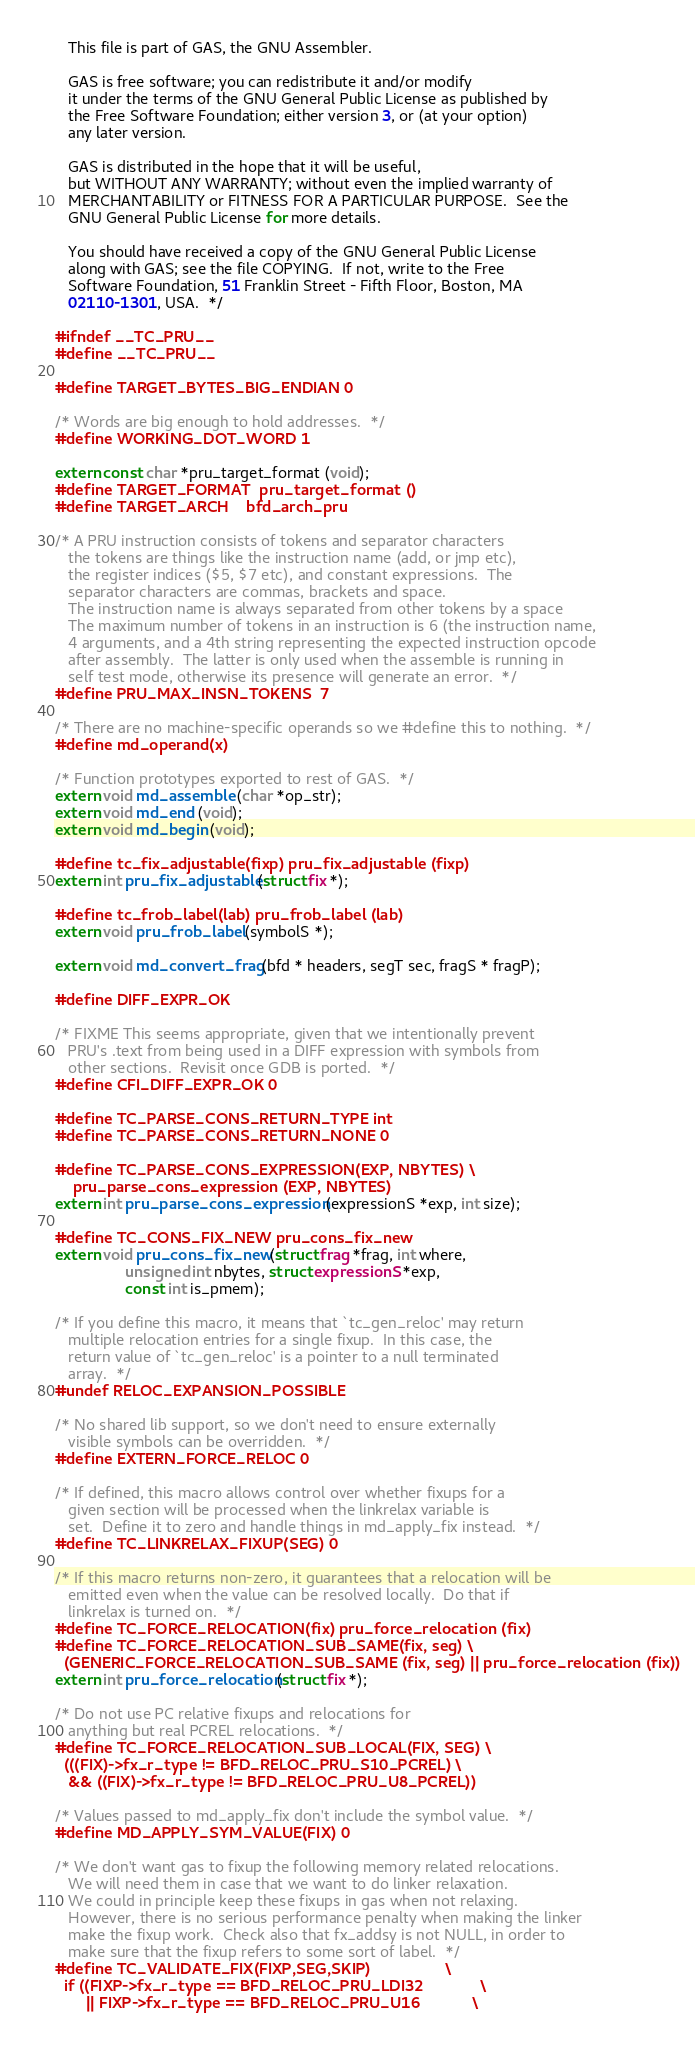Convert code to text. <code><loc_0><loc_0><loc_500><loc_500><_C_>   This file is part of GAS, the GNU Assembler.

   GAS is free software; you can redistribute it and/or modify
   it under the terms of the GNU General Public License as published by
   the Free Software Foundation; either version 3, or (at your option)
   any later version.

   GAS is distributed in the hope that it will be useful,
   but WITHOUT ANY WARRANTY; without even the implied warranty of
   MERCHANTABILITY or FITNESS FOR A PARTICULAR PURPOSE.  See the
   GNU General Public License for more details.

   You should have received a copy of the GNU General Public License
   along with GAS; see the file COPYING.  If not, write to the Free
   Software Foundation, 51 Franklin Street - Fifth Floor, Boston, MA
   02110-1301, USA.  */

#ifndef __TC_PRU__
#define __TC_PRU__

#define TARGET_BYTES_BIG_ENDIAN 0

/* Words are big enough to hold addresses.  */
#define WORKING_DOT_WORD	1

extern const char *pru_target_format (void);
#define TARGET_FORMAT  pru_target_format ()
#define TARGET_ARCH    bfd_arch_pru

/* A PRU instruction consists of tokens and separator characters
   the tokens are things like the instruction name (add, or jmp etc),
   the register indices ($5, $7 etc), and constant expressions.  The
   separator characters are commas, brackets and space.
   The instruction name is always separated from other tokens by a space
   The maximum number of tokens in an instruction is 6 (the instruction name,
   4 arguments, and a 4th string representing the expected instruction opcode
   after assembly.  The latter is only used when the assemble is running in
   self test mode, otherwise its presence will generate an error.  */
#define PRU_MAX_INSN_TOKENS	7

/* There are no machine-specific operands so we #define this to nothing.  */
#define md_operand(x)

/* Function prototypes exported to rest of GAS.  */
extern void md_assemble (char *op_str);
extern void md_end (void);
extern void md_begin (void);

#define tc_fix_adjustable(fixp) pru_fix_adjustable (fixp)
extern int pru_fix_adjustable (struct fix *);

#define tc_frob_label(lab) pru_frob_label (lab)
extern void pru_frob_label (symbolS *);

extern void md_convert_frag (bfd * headers, segT sec, fragS * fragP);

#define DIFF_EXPR_OK

/* FIXME This seems appropriate, given that we intentionally prevent
   PRU's .text from being used in a DIFF expression with symbols from
   other sections.  Revisit once GDB is ported.  */
#define CFI_DIFF_EXPR_OK 0

#define TC_PARSE_CONS_RETURN_TYPE int
#define TC_PARSE_CONS_RETURN_NONE 0

#define TC_PARSE_CONS_EXPRESSION(EXP, NBYTES) \
	pru_parse_cons_expression (EXP, NBYTES)
extern int pru_parse_cons_expression (expressionS *exp, int size);

#define TC_CONS_FIX_NEW pru_cons_fix_new
extern void pru_cons_fix_new (struct frag *frag, int where,
				unsigned int nbytes, struct expressionS *exp,
				const int is_pmem);

/* If you define this macro, it means that `tc_gen_reloc' may return
   multiple relocation entries for a single fixup.  In this case, the
   return value of `tc_gen_reloc' is a pointer to a null terminated
   array.  */
#undef RELOC_EXPANSION_POSSIBLE

/* No shared lib support, so we don't need to ensure externally
   visible symbols can be overridden.  */
#define EXTERN_FORCE_RELOC 0

/* If defined, this macro allows control over whether fixups for a
   given section will be processed when the linkrelax variable is
   set.  Define it to zero and handle things in md_apply_fix instead.  */
#define TC_LINKRELAX_FIXUP(SEG) 0

/* If this macro returns non-zero, it guarantees that a relocation will be
   emitted even when the value can be resolved locally.  Do that if
   linkrelax is turned on.  */
#define TC_FORCE_RELOCATION(fix)	pru_force_relocation (fix)
#define TC_FORCE_RELOCATION_SUB_SAME(fix, seg) \
  (GENERIC_FORCE_RELOCATION_SUB_SAME (fix, seg) || pru_force_relocation (fix))
extern int pru_force_relocation (struct fix *);

/* Do not use PC relative fixups and relocations for
   anything but real PCREL relocations.  */
#define TC_FORCE_RELOCATION_SUB_LOCAL(FIX, SEG) \
  (((FIX)->fx_r_type != BFD_RELOC_PRU_S10_PCREL) \
   && ((FIX)->fx_r_type != BFD_RELOC_PRU_U8_PCREL))

/* Values passed to md_apply_fix don't include the symbol value.  */
#define MD_APPLY_SYM_VALUE(FIX) 0

/* We don't want gas to fixup the following memory related relocations.
   We will need them in case that we want to do linker relaxation.
   We could in principle keep these fixups in gas when not relaxing.
   However, there is no serious performance penalty when making the linker
   make the fixup work.  Check also that fx_addsy is not NULL, in order to
   make sure that the fixup refers to some sort of label.  */
#define TC_VALIDATE_FIX(FIXP,SEG,SKIP)			      \
  if ((FIXP->fx_r_type == BFD_RELOC_PRU_LDI32		      \
       || FIXP->fx_r_type == BFD_RELOC_PRU_U16		      \</code> 